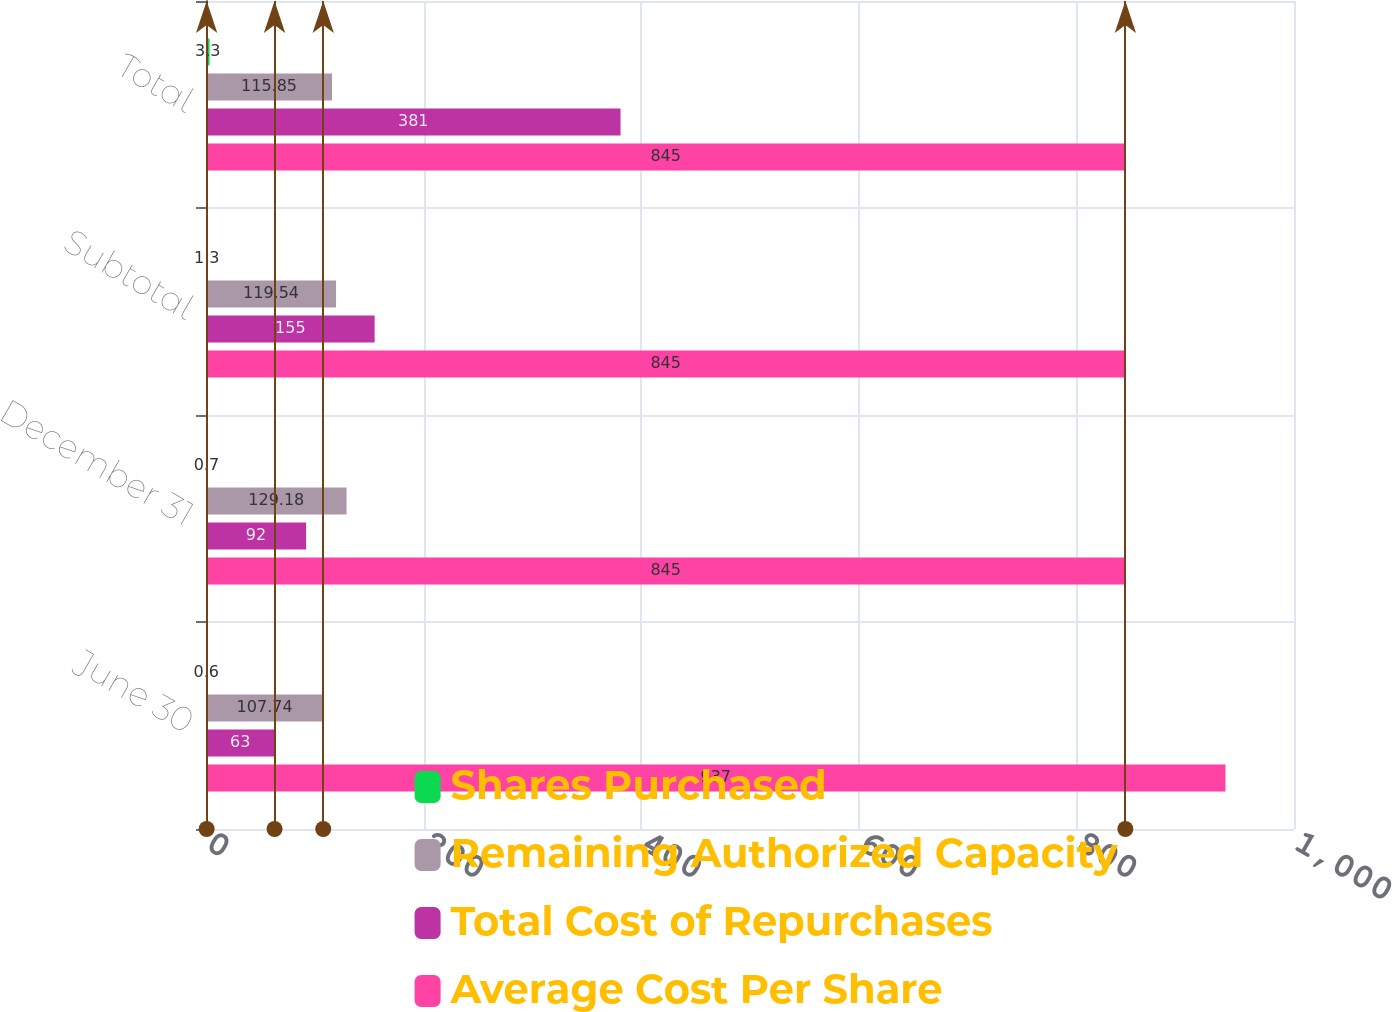Convert chart to OTSL. <chart><loc_0><loc_0><loc_500><loc_500><stacked_bar_chart><ecel><fcel>June 30<fcel>December 31<fcel>Subtotal<fcel>Total<nl><fcel>Shares Purchased<fcel>0.6<fcel>0.7<fcel>1.3<fcel>3.3<nl><fcel>Remaining Authorized Capacity<fcel>107.74<fcel>129.18<fcel>119.54<fcel>115.85<nl><fcel>Total Cost of Repurchases<fcel>63<fcel>92<fcel>155<fcel>381<nl><fcel>Average Cost Per Share<fcel>937<fcel>845<fcel>845<fcel>845<nl></chart> 